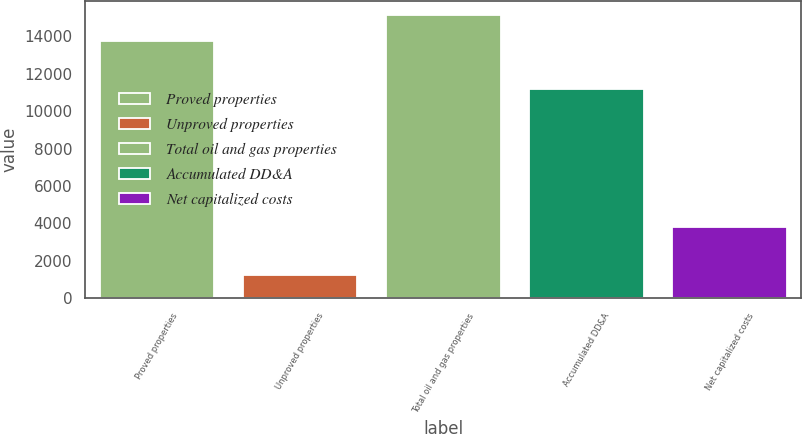<chart> <loc_0><loc_0><loc_500><loc_500><bar_chart><fcel>Proved properties<fcel>Unproved properties<fcel>Total oil and gas properties<fcel>Accumulated DD&A<fcel>Net capitalized costs<nl><fcel>13747<fcel>1232<fcel>15121.7<fcel>11185<fcel>3794<nl></chart> 